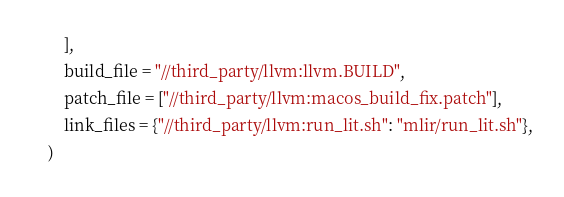<code> <loc_0><loc_0><loc_500><loc_500><_Python_>        ],
        build_file = "//third_party/llvm:llvm.BUILD",
        patch_file = ["//third_party/llvm:macos_build_fix.patch"],
        link_files = {"//third_party/llvm:run_lit.sh": "mlir/run_lit.sh"},
    )
</code> 